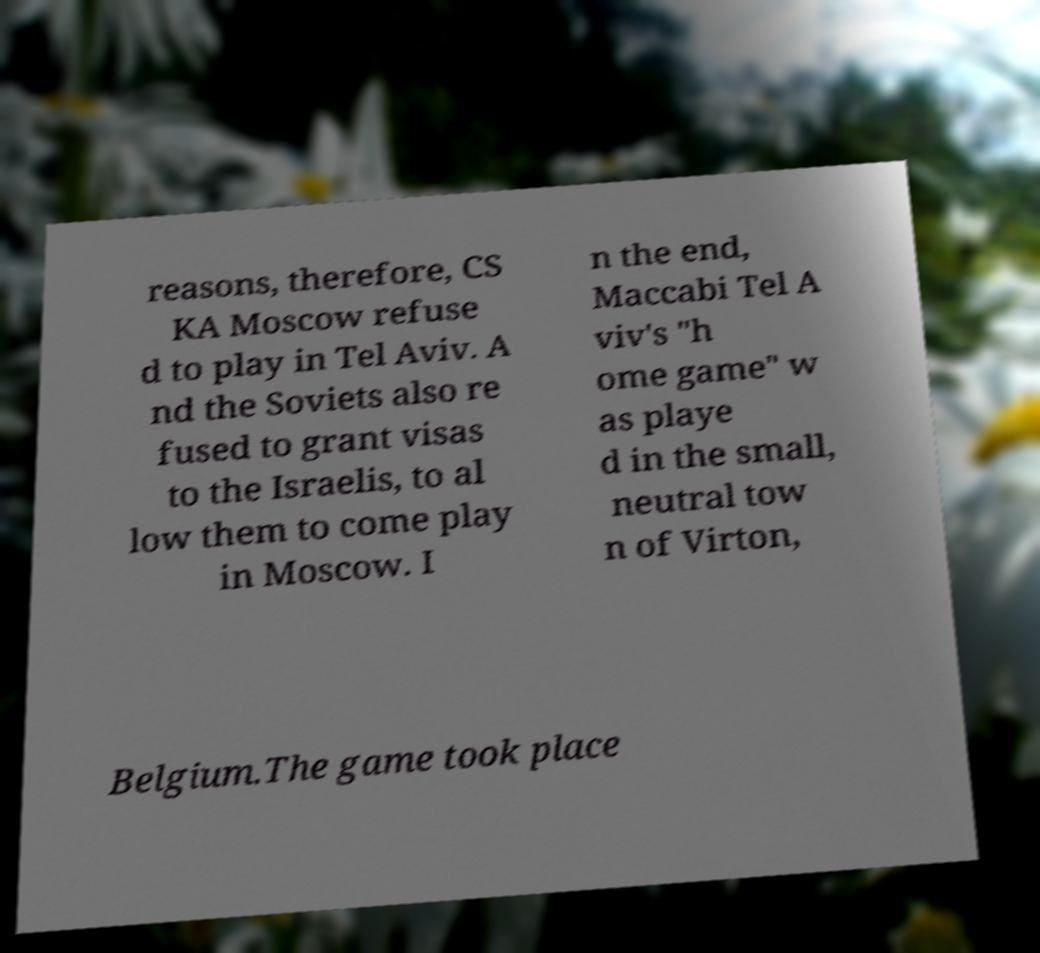For documentation purposes, I need the text within this image transcribed. Could you provide that? reasons, therefore, CS KA Moscow refuse d to play in Tel Aviv. A nd the Soviets also re fused to grant visas to the Israelis, to al low them to come play in Moscow. I n the end, Maccabi Tel A viv's "h ome game" w as playe d in the small, neutral tow n of Virton, Belgium.The game took place 